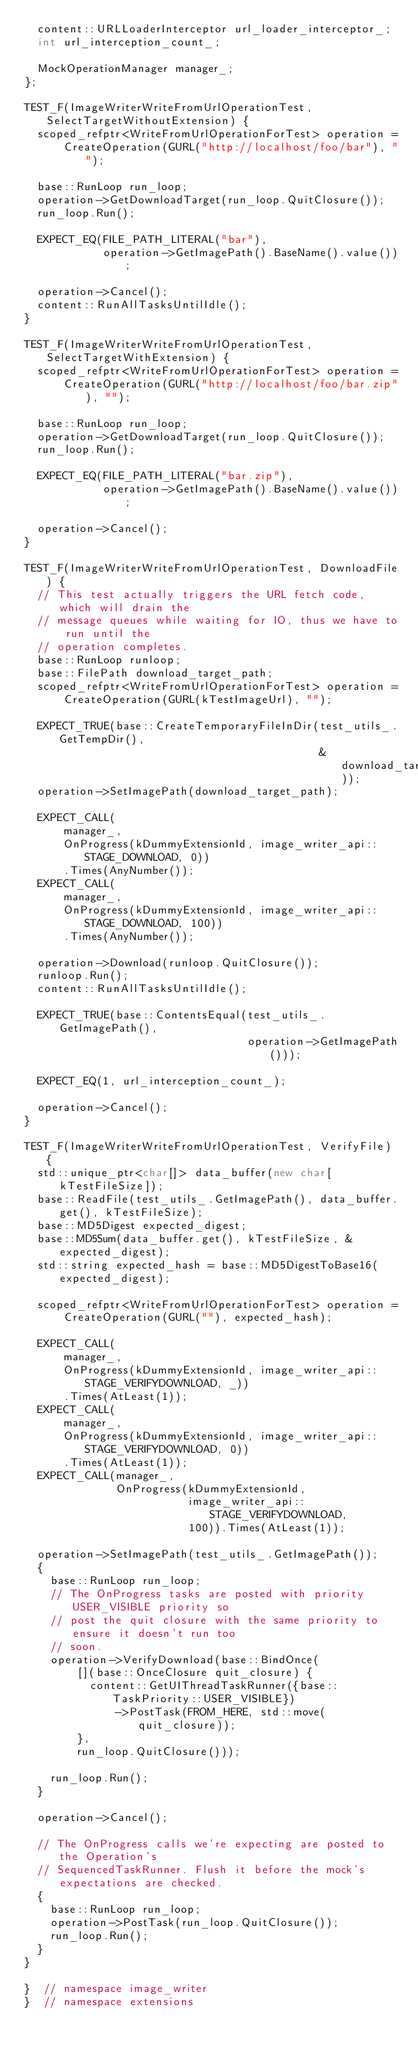Convert code to text. <code><loc_0><loc_0><loc_500><loc_500><_C++_>  content::URLLoaderInterceptor url_loader_interceptor_;
  int url_interception_count_;

  MockOperationManager manager_;
};

TEST_F(ImageWriterWriteFromUrlOperationTest, SelectTargetWithoutExtension) {
  scoped_refptr<WriteFromUrlOperationForTest> operation =
      CreateOperation(GURL("http://localhost/foo/bar"), "");

  base::RunLoop run_loop;
  operation->GetDownloadTarget(run_loop.QuitClosure());
  run_loop.Run();

  EXPECT_EQ(FILE_PATH_LITERAL("bar"),
            operation->GetImagePath().BaseName().value());

  operation->Cancel();
  content::RunAllTasksUntilIdle();
}

TEST_F(ImageWriterWriteFromUrlOperationTest, SelectTargetWithExtension) {
  scoped_refptr<WriteFromUrlOperationForTest> operation =
      CreateOperation(GURL("http://localhost/foo/bar.zip"), "");

  base::RunLoop run_loop;
  operation->GetDownloadTarget(run_loop.QuitClosure());
  run_loop.Run();

  EXPECT_EQ(FILE_PATH_LITERAL("bar.zip"),
            operation->GetImagePath().BaseName().value());

  operation->Cancel();
}

TEST_F(ImageWriterWriteFromUrlOperationTest, DownloadFile) {
  // This test actually triggers the URL fetch code, which will drain the
  // message queues while waiting for IO, thus we have to run until the
  // operation completes.
  base::RunLoop runloop;
  base::FilePath download_target_path;
  scoped_refptr<WriteFromUrlOperationForTest> operation =
      CreateOperation(GURL(kTestImageUrl), "");

  EXPECT_TRUE(base::CreateTemporaryFileInDir(test_utils_.GetTempDir(),
                                             &download_target_path));
  operation->SetImagePath(download_target_path);

  EXPECT_CALL(
      manager_,
      OnProgress(kDummyExtensionId, image_writer_api::STAGE_DOWNLOAD, 0))
      .Times(AnyNumber());
  EXPECT_CALL(
      manager_,
      OnProgress(kDummyExtensionId, image_writer_api::STAGE_DOWNLOAD, 100))
      .Times(AnyNumber());

  operation->Download(runloop.QuitClosure());
  runloop.Run();
  content::RunAllTasksUntilIdle();

  EXPECT_TRUE(base::ContentsEqual(test_utils_.GetImagePath(),
                                  operation->GetImagePath()));

  EXPECT_EQ(1, url_interception_count_);

  operation->Cancel();
}

TEST_F(ImageWriterWriteFromUrlOperationTest, VerifyFile) {
  std::unique_ptr<char[]> data_buffer(new char[kTestFileSize]);
  base::ReadFile(test_utils_.GetImagePath(), data_buffer.get(), kTestFileSize);
  base::MD5Digest expected_digest;
  base::MD5Sum(data_buffer.get(), kTestFileSize, &expected_digest);
  std::string expected_hash = base::MD5DigestToBase16(expected_digest);

  scoped_refptr<WriteFromUrlOperationForTest> operation =
      CreateOperation(GURL(""), expected_hash);

  EXPECT_CALL(
      manager_,
      OnProgress(kDummyExtensionId, image_writer_api::STAGE_VERIFYDOWNLOAD, _))
      .Times(AtLeast(1));
  EXPECT_CALL(
      manager_,
      OnProgress(kDummyExtensionId, image_writer_api::STAGE_VERIFYDOWNLOAD, 0))
      .Times(AtLeast(1));
  EXPECT_CALL(manager_,
              OnProgress(kDummyExtensionId,
                         image_writer_api::STAGE_VERIFYDOWNLOAD,
                         100)).Times(AtLeast(1));

  operation->SetImagePath(test_utils_.GetImagePath());
  {
    base::RunLoop run_loop;
    // The OnProgress tasks are posted with priority USER_VISIBLE priority so
    // post the quit closure with the same priority to ensure it doesn't run too
    // soon.
    operation->VerifyDownload(base::BindOnce(
        [](base::OnceClosure quit_closure) {
          content::GetUIThreadTaskRunner({base::TaskPriority::USER_VISIBLE})
              ->PostTask(FROM_HERE, std::move(quit_closure));
        },
        run_loop.QuitClosure()));

    run_loop.Run();
  }

  operation->Cancel();

  // The OnProgress calls we're expecting are posted to the Operation's
  // SequencedTaskRunner. Flush it before the mock's expectations are checked.
  {
    base::RunLoop run_loop;
    operation->PostTask(run_loop.QuitClosure());
    run_loop.Run();
  }
}

}  // namespace image_writer
}  // namespace extensions
</code> 